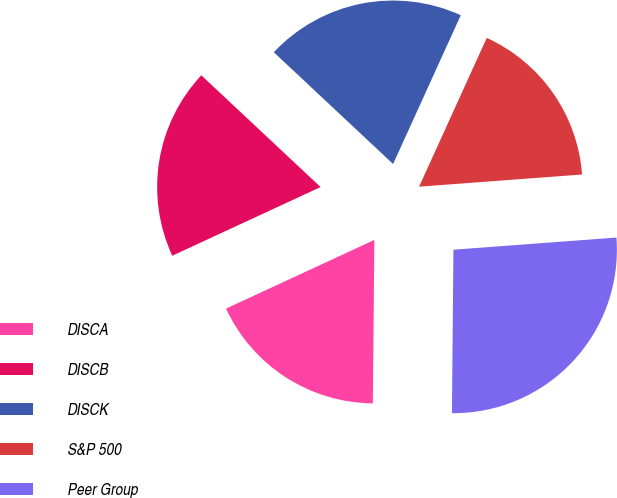Convert chart. <chart><loc_0><loc_0><loc_500><loc_500><pie_chart><fcel>DISCA<fcel>DISCB<fcel>DISCK<fcel>S&P 500<fcel>Peer Group<nl><fcel>17.95%<fcel>18.88%<fcel>19.81%<fcel>17.02%<fcel>26.33%<nl></chart> 